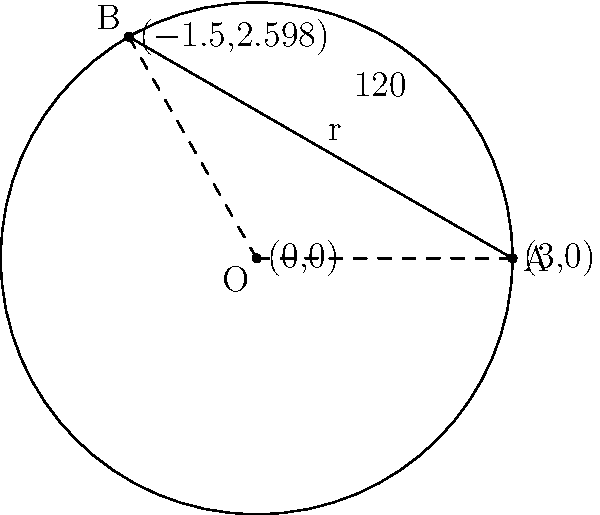During an excavation of a circular Slavic ritual site, you discover a circular arrangement of artifacts with a radius of 5 meters. Two artifacts are positioned on the circle's circumference, forming a central angle of 120°. Calculate the length of the chord connecting these two artifacts to the nearest centimeter. To solve this problem, we'll use the formula for the length of a chord given the radius and central angle. Let's approach this step-by-step:

1) The formula for the length of a chord is:
   $$c = 2r \sin(\frac{\theta}{2})$$
   where $c$ is the chord length, $r$ is the radius, and $\theta$ is the central angle in radians.

2) We're given:
   - Radius $r = 5$ meters
   - Central angle $\theta = 120°$

3) First, we need to convert the angle from degrees to radians:
   $$120° \times \frac{\pi}{180°} = \frac{2\pi}{3}$$ radians

4) Now we can substitute these values into our formula:
   $$c = 2 \times 5 \times \sin(\frac{\frac{2\pi}{3}}{2})$$

5) Simplify:
   $$c = 10 \times \sin(\frac{\pi}{3})$$

6) We know that $\sin(\frac{\pi}{3}) = \frac{\sqrt{3}}{2}$, so:
   $$c = 10 \times \frac{\sqrt{3}}{2} = 5\sqrt{3}$$

7) Calculate the value:
   $$5\sqrt{3} \approx 8.660254$$

8) Rounding to the nearest centimeter:
   $$8.66$$ meters or $$866$$ cm

Therefore, the length of the chord connecting the two artifacts is approximately 8.66 meters or 866 centimeters.
Answer: 866 cm 